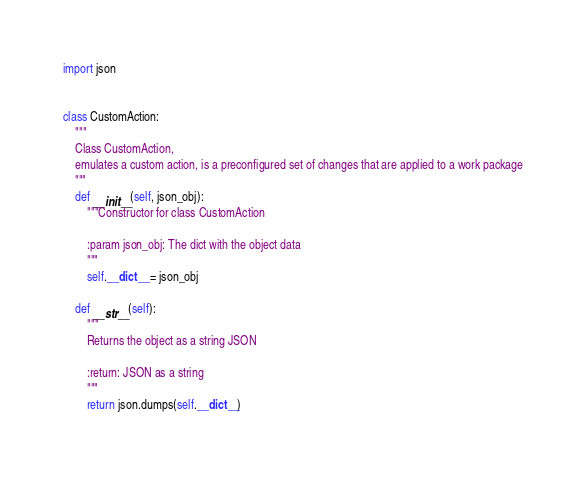Convert code to text. <code><loc_0><loc_0><loc_500><loc_500><_Python_>import json


class CustomAction:
    """
    Class CustomAction,
    emulates a custom action, is a preconfigured set of changes that are applied to a work package
    """
    def __init__(self, json_obj):
        """Constructor for class CustomAction

        :param json_obj: The dict with the object data
        """
        self.__dict__ = json_obj

    def __str__(self):
        """
        Returns the object as a string JSON

        :return: JSON as a string
        """
        return json.dumps(self.__dict__)
</code> 